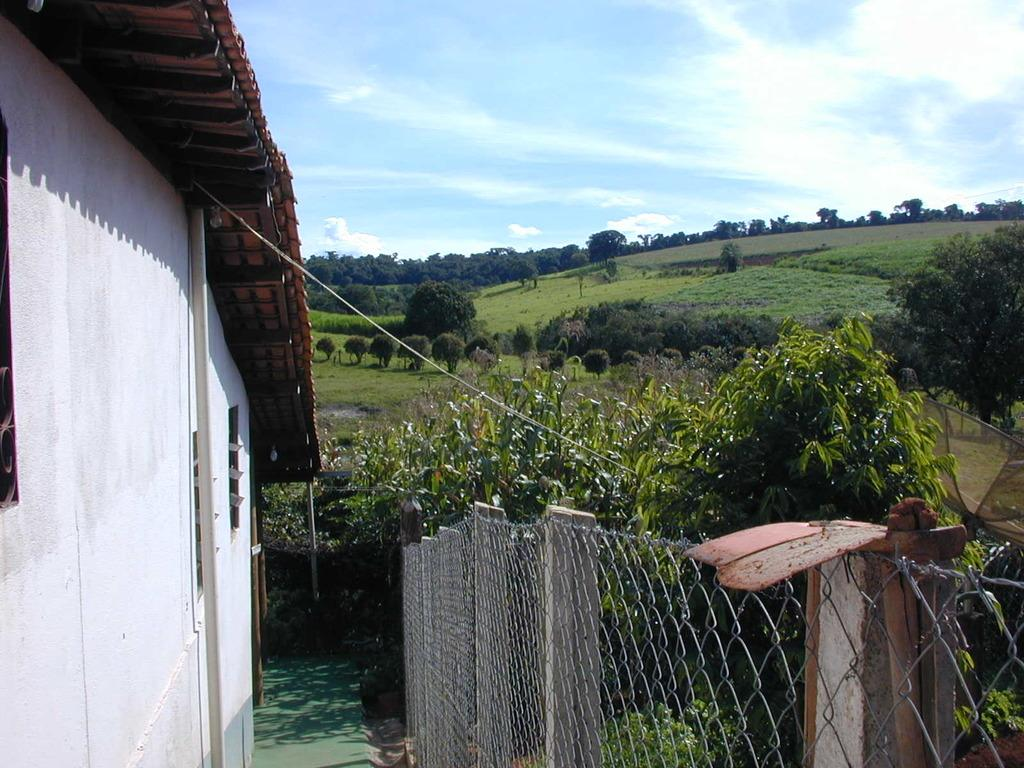What is located in the foreground of the image? There is a fencing in the foreground of the image. What can be seen on the right side of the foreground? There are plants on the right side of the foreground. What is on the left side of the image? There is a building on the left side of the image. What is visible in the background of the image? Trees, grass, and the sky are visible in the background. Can you describe the sky in the image? The sky is visible in the background, and there is a cloud in the sky. What shape is the sugar in the image? There is no sugar present in the image. How is the glue being used in the image? There is no glue present in the image. 